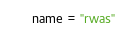<code> <loc_0><loc_0><loc_500><loc_500><_Python_>name = "rwas"</code> 